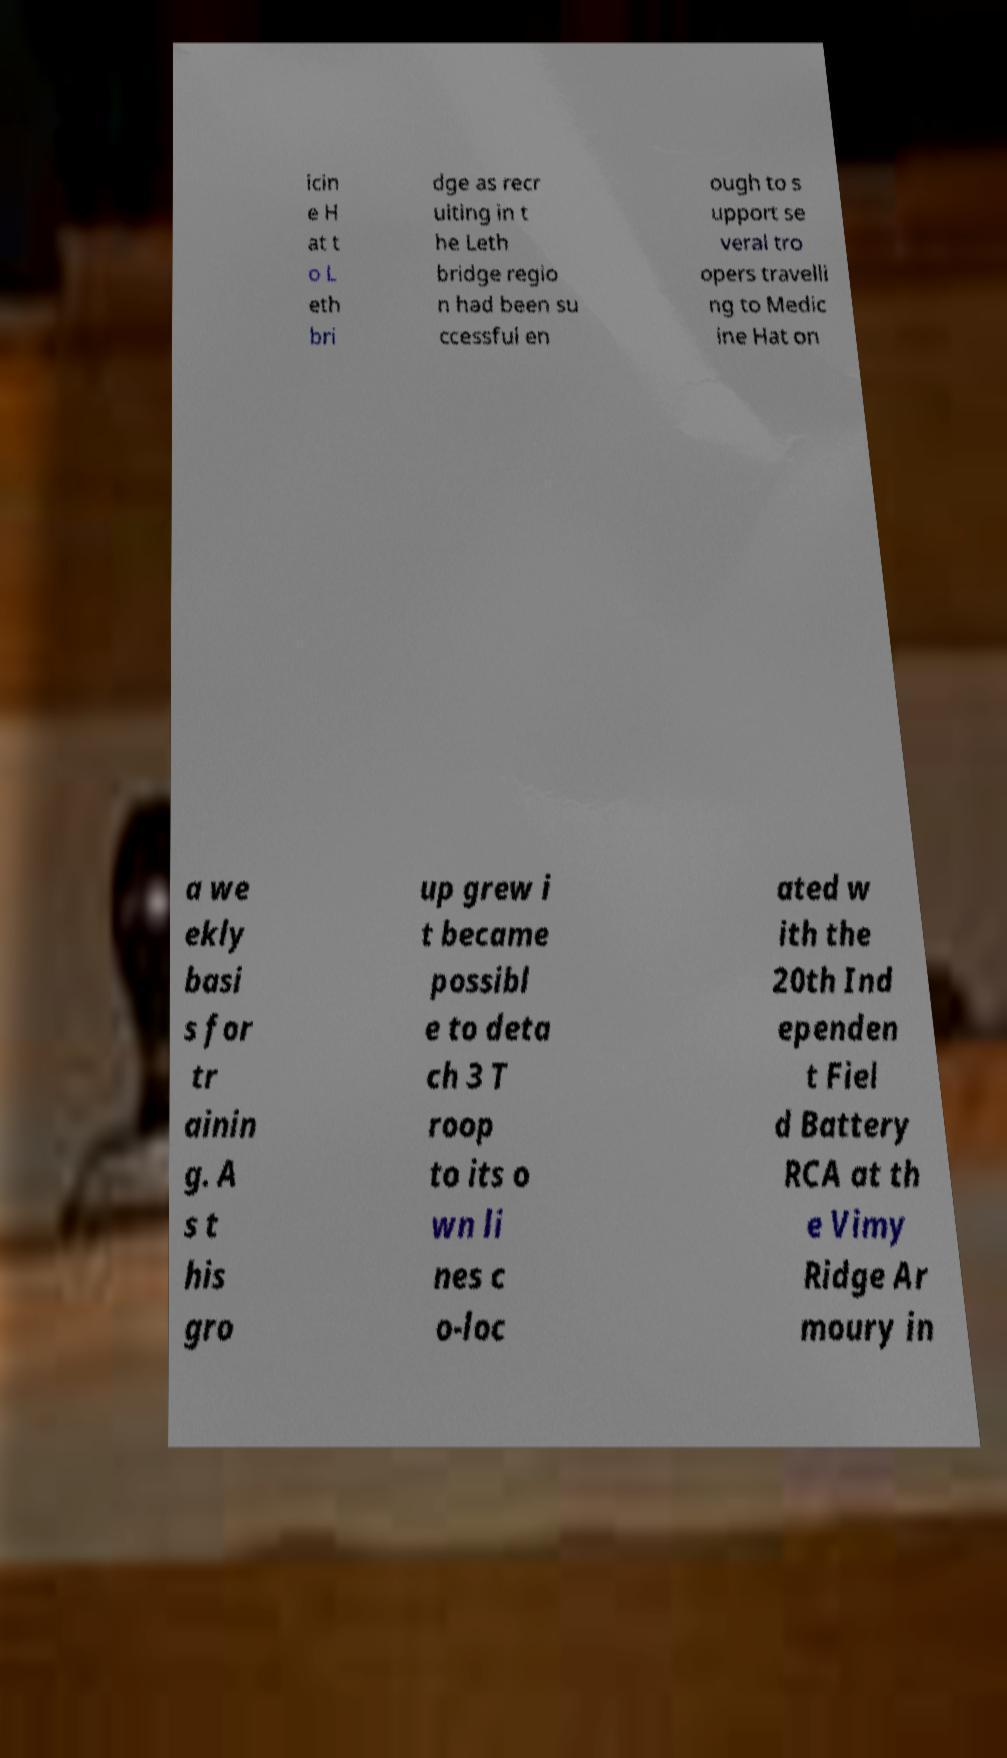Can you read and provide the text displayed in the image?This photo seems to have some interesting text. Can you extract and type it out for me? icin e H at t o L eth bri dge as recr uiting in t he Leth bridge regio n had been su ccessful en ough to s upport se veral tro opers travelli ng to Medic ine Hat on a we ekly basi s for tr ainin g. A s t his gro up grew i t became possibl e to deta ch 3 T roop to its o wn li nes c o-loc ated w ith the 20th Ind ependen t Fiel d Battery RCA at th e Vimy Ridge Ar moury in 